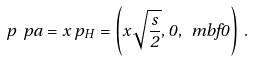<formula> <loc_0><loc_0><loc_500><loc_500>p _ { \ } p a = x \, p _ { H } = \left ( x \sqrt { \frac { s } { 2 } } , 0 , \ m b f { 0 } \right ) \, .</formula> 